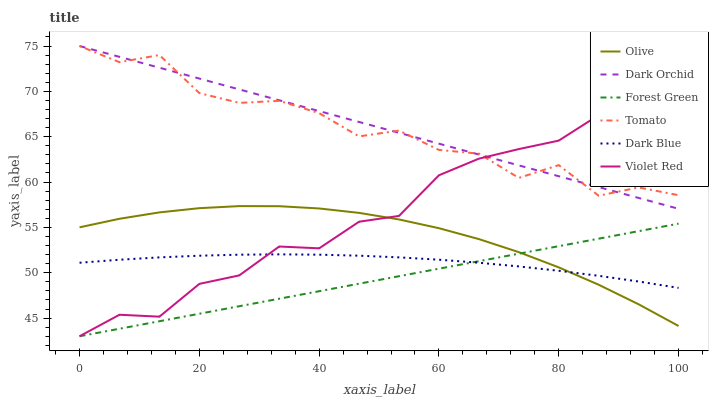Does Violet Red have the minimum area under the curve?
Answer yes or no. No. Does Violet Red have the maximum area under the curve?
Answer yes or no. No. Is Violet Red the smoothest?
Answer yes or no. No. Is Violet Red the roughest?
Answer yes or no. No. Does Dark Orchid have the lowest value?
Answer yes or no. No. Does Violet Red have the highest value?
Answer yes or no. No. Is Olive less than Tomato?
Answer yes or no. Yes. Is Tomato greater than Forest Green?
Answer yes or no. Yes. Does Olive intersect Tomato?
Answer yes or no. No. 